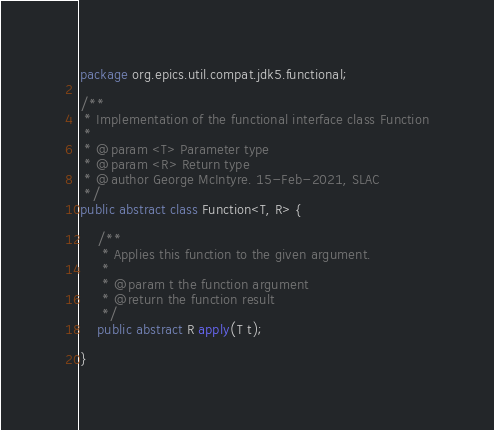<code> <loc_0><loc_0><loc_500><loc_500><_Java_>package org.epics.util.compat.jdk5.functional;

/**
 * Implementation of the functional interface class Function
 *
 * @param <T> Parameter type
 * @param <R> Return type
 * @author George McIntyre. 15-Feb-2021, SLAC
 */
public abstract class Function<T, R> {

    /**
     * Applies this function to the given argument.
     *
     * @param t the function argument
     * @return the function result
     */
    public abstract R apply(T t);

}
</code> 